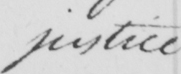Can you read and transcribe this handwriting? justice 